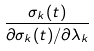Convert formula to latex. <formula><loc_0><loc_0><loc_500><loc_500>\frac { \sigma _ { k } ( t ) } { \partial \sigma _ { k } ( t ) / \partial \lambda _ { k } }</formula> 